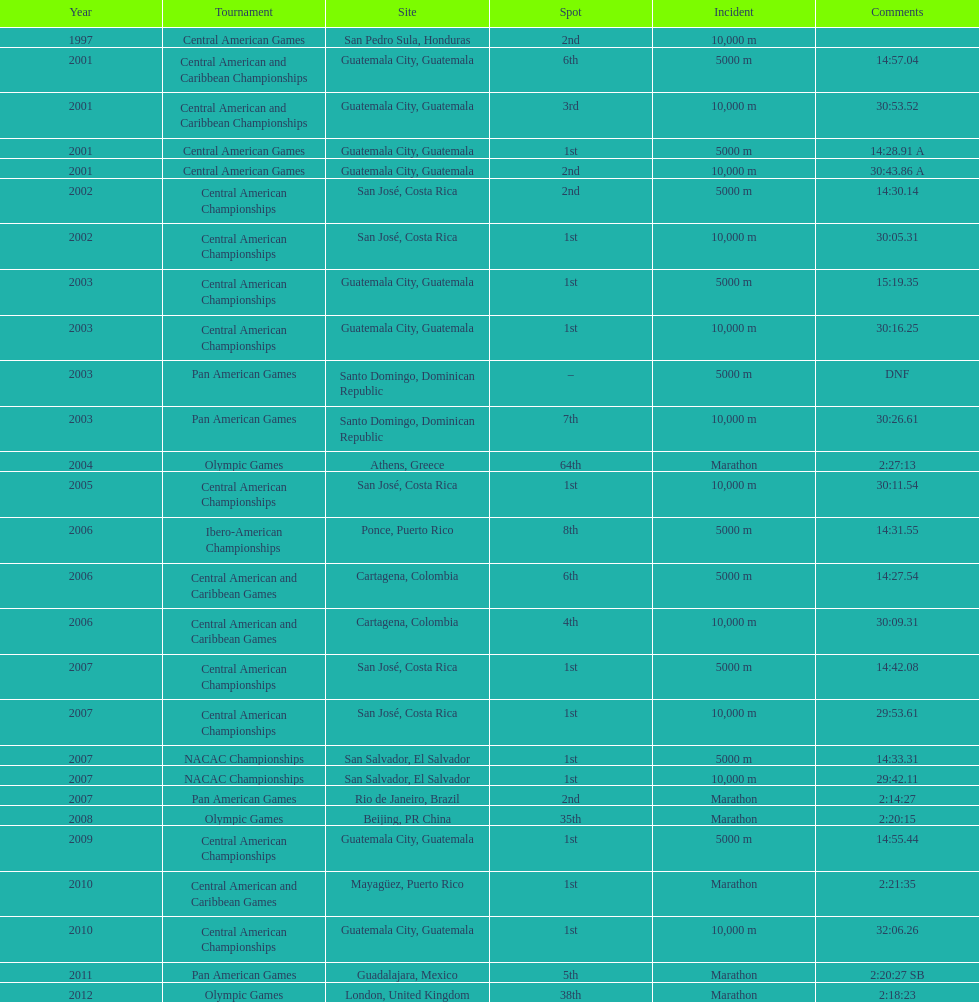I'm looking to parse the entire table for insights. Could you assist me with that? {'header': ['Year', 'Tournament', 'Site', 'Spot', 'Incident', 'Comments'], 'rows': [['1997', 'Central American Games', 'San Pedro Sula, Honduras', '2nd', '10,000 m', ''], ['2001', 'Central American and Caribbean Championships', 'Guatemala City, Guatemala', '6th', '5000 m', '14:57.04'], ['2001', 'Central American and Caribbean Championships', 'Guatemala City, Guatemala', '3rd', '10,000 m', '30:53.52'], ['2001', 'Central American Games', 'Guatemala City, Guatemala', '1st', '5000 m', '14:28.91 A'], ['2001', 'Central American Games', 'Guatemala City, Guatemala', '2nd', '10,000 m', '30:43.86 A'], ['2002', 'Central American Championships', 'San José, Costa Rica', '2nd', '5000 m', '14:30.14'], ['2002', 'Central American Championships', 'San José, Costa Rica', '1st', '10,000 m', '30:05.31'], ['2003', 'Central American Championships', 'Guatemala City, Guatemala', '1st', '5000 m', '15:19.35'], ['2003', 'Central American Championships', 'Guatemala City, Guatemala', '1st', '10,000 m', '30:16.25'], ['2003', 'Pan American Games', 'Santo Domingo, Dominican Republic', '–', '5000 m', 'DNF'], ['2003', 'Pan American Games', 'Santo Domingo, Dominican Republic', '7th', '10,000 m', '30:26.61'], ['2004', 'Olympic Games', 'Athens, Greece', '64th', 'Marathon', '2:27:13'], ['2005', 'Central American Championships', 'San José, Costa Rica', '1st', '10,000 m', '30:11.54'], ['2006', 'Ibero-American Championships', 'Ponce, Puerto Rico', '8th', '5000 m', '14:31.55'], ['2006', 'Central American and Caribbean Games', 'Cartagena, Colombia', '6th', '5000 m', '14:27.54'], ['2006', 'Central American and Caribbean Games', 'Cartagena, Colombia', '4th', '10,000 m', '30:09.31'], ['2007', 'Central American Championships', 'San José, Costa Rica', '1st', '5000 m', '14:42.08'], ['2007', 'Central American Championships', 'San José, Costa Rica', '1st', '10,000 m', '29:53.61'], ['2007', 'NACAC Championships', 'San Salvador, El Salvador', '1st', '5000 m', '14:33.31'], ['2007', 'NACAC Championships', 'San Salvador, El Salvador', '1st', '10,000 m', '29:42.11'], ['2007', 'Pan American Games', 'Rio de Janeiro, Brazil', '2nd', 'Marathon', '2:14:27'], ['2008', 'Olympic Games', 'Beijing, PR China', '35th', 'Marathon', '2:20:15'], ['2009', 'Central American Championships', 'Guatemala City, Guatemala', '1st', '5000 m', '14:55.44'], ['2010', 'Central American and Caribbean Games', 'Mayagüez, Puerto Rico', '1st', 'Marathon', '2:21:35'], ['2010', 'Central American Championships', 'Guatemala City, Guatemala', '1st', '10,000 m', '32:06.26'], ['2011', 'Pan American Games', 'Guadalajara, Mexico', '5th', 'Marathon', '2:20:27 SB'], ['2012', 'Olympic Games', 'London, United Kingdom', '38th', 'Marathon', '2:18:23']]} Which event is listed more between the 10,000m and the 5000m? 10,000 m. 